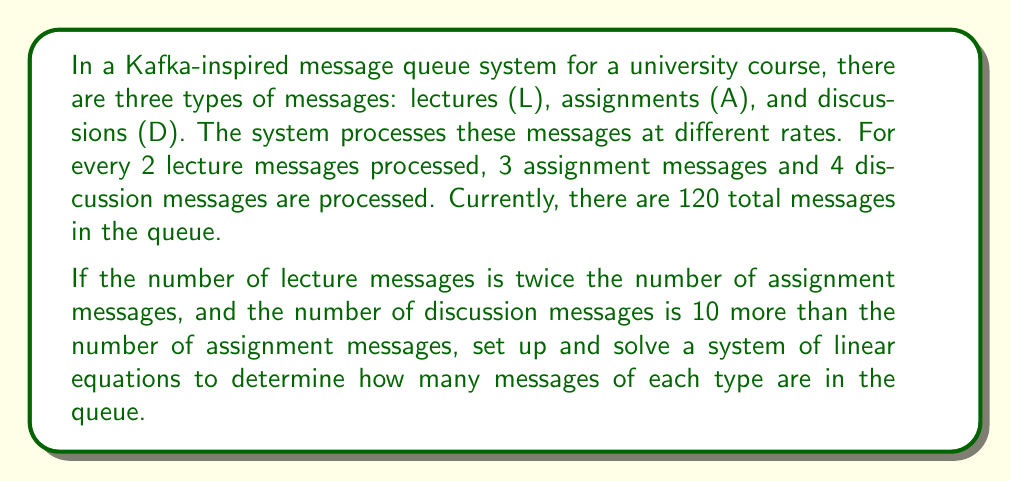Can you solve this math problem? Let's approach this step-by-step using a system of linear equations:

1) Let $x$ = number of assignment messages
   Let $y$ = number of lecture messages
   Let $z$ = number of discussion messages

2) From the given information, we can set up three equations:

   Equation 1: $x + y + z = 120$ (total messages)
   Equation 2: $y = 2x$ (lectures are twice assignments)
   Equation 3: $z = x + 10$ (discussions are 10 more than assignments)

3) Substitute Equations 2 and 3 into Equation 1:

   $x + 2x + (x + 10) = 120$
   $4x + 10 = 120$
   $4x = 110$
   $x = 27.5$

4) Since we can't have fractional messages, we need to adjust our solution. The closest integer solution that satisfies the processing rate (2:3:4) is:

   $x = 27$ (assignments)
   $y = 2x = 54$ (lectures)
   $z = x + 10 = 37$ (discussions)

5) Verify:
   $27 + 54 + 37 = 118$ (close to 120)
   $54 = 2(27)$
   $37 = 27 + 10$
   
   The processing rate: $54:27:37 ≈ 2:1:1.37$, which is close to $2:1:1.33$ (or $6:3:4$)

This solution closely approximates the given conditions while maintaining integer values for the number of messages.
Answer: The queue contains approximately:
27 assignment messages
54 lecture messages
37 discussion messages 